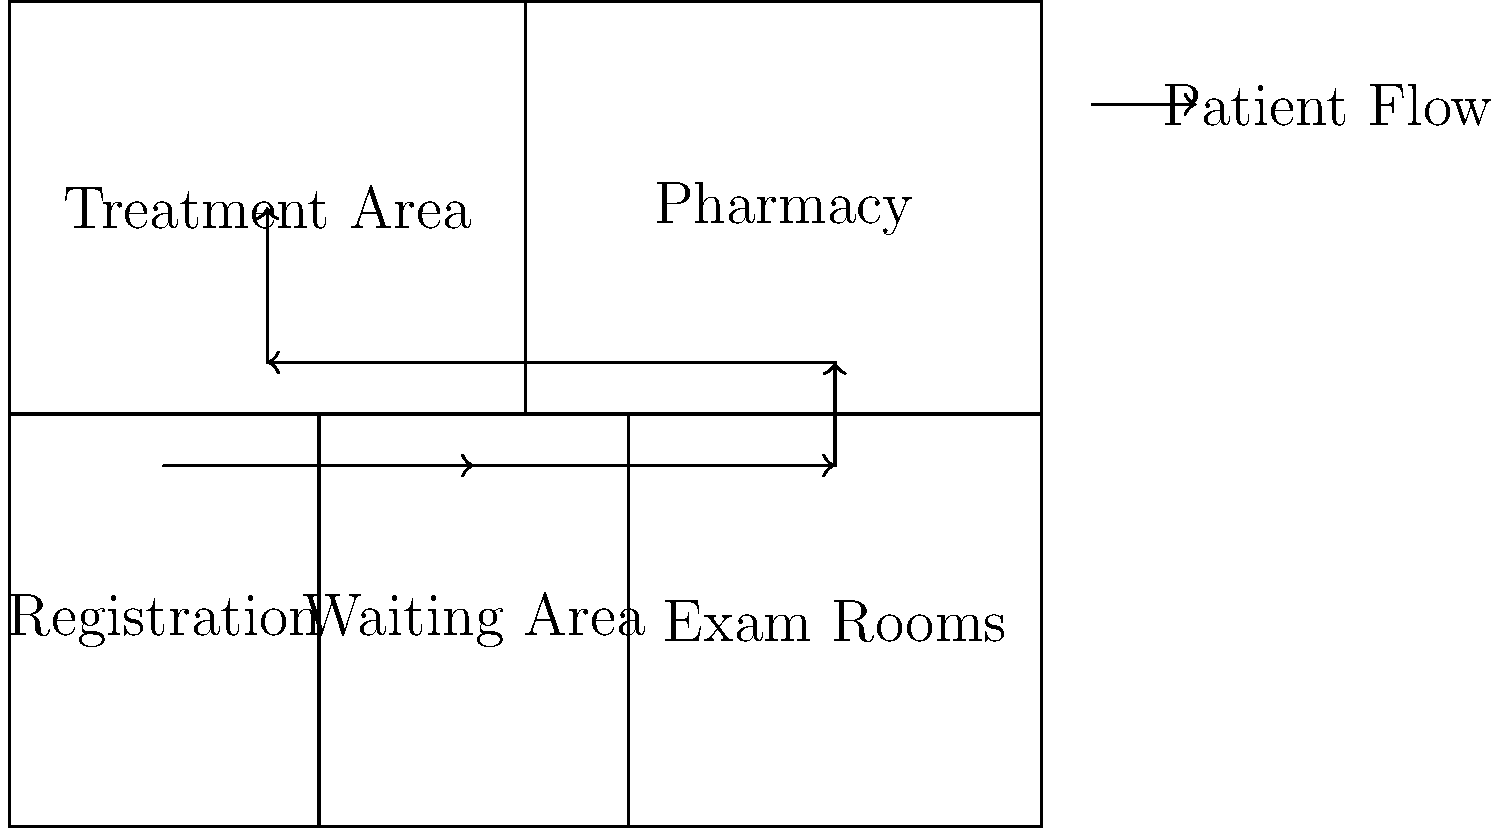Based on the hospital floor plan diagram, which modification to the patient flow would most likely reduce wait times and improve overall efficiency for cancer patients receiving treatment? To optimize patient flow and reduce wait times, we need to analyze the current flow and identify potential bottlenecks:

1. Current flow: Registration → Waiting Area → Exam Rooms → Treatment Area
2. Potential bottlenecks:
   a. Waiting Area: Patients may spend excessive time here between registration and exams.
   b. Exam Rooms: Limited number of rooms may cause delays.
   c. Treatment Area: Patients must travel back through the facility to reach it.

3. Optimal solution: Create a direct path from Exam Rooms to Treatment Area
   - This modification would:
     a. Reduce travel time for patients
     b. Minimize congestion in the Waiting Area
     c. Allow for a more efficient use of Exam Rooms
     d. Potentially enable parallel processing (e.g., pharmacy preparation during exams)

4. Implementation:
   - Add a door or passage between Exam Rooms and Treatment Area
   - Adjust the patient flow to: Registration → Waiting Area → Exam Rooms → Treatment Area (directly)

5. Benefits:
   - Shorter overall treatment time
   - Reduced wait times between steps
   - Improved patient satisfaction
   - More efficient use of hospital resources

This modification aligns with the goal of streamlining administrative processes and reducing barriers to quality care for cancer patients.
Answer: Add a direct path from Exam Rooms to Treatment Area 